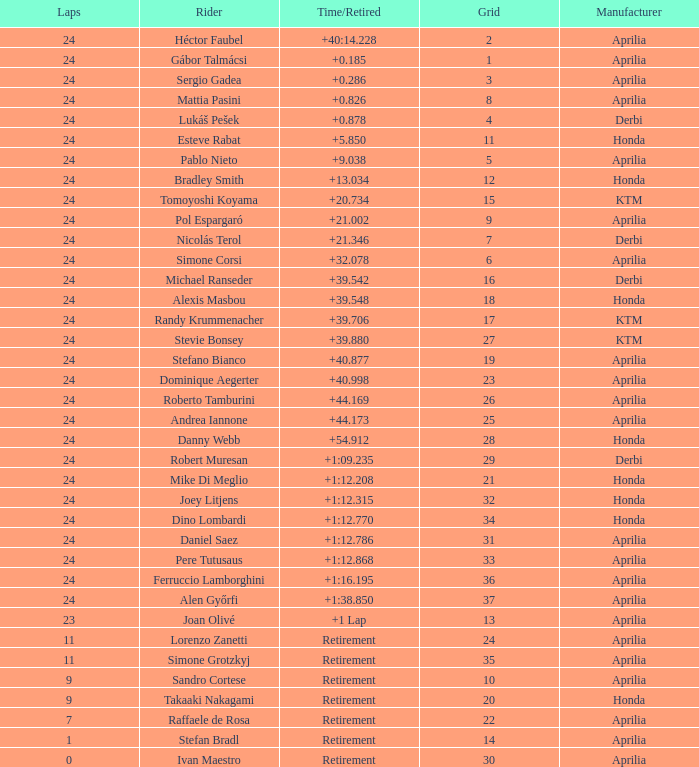How many grids correspond to more than 24 laps? None. 